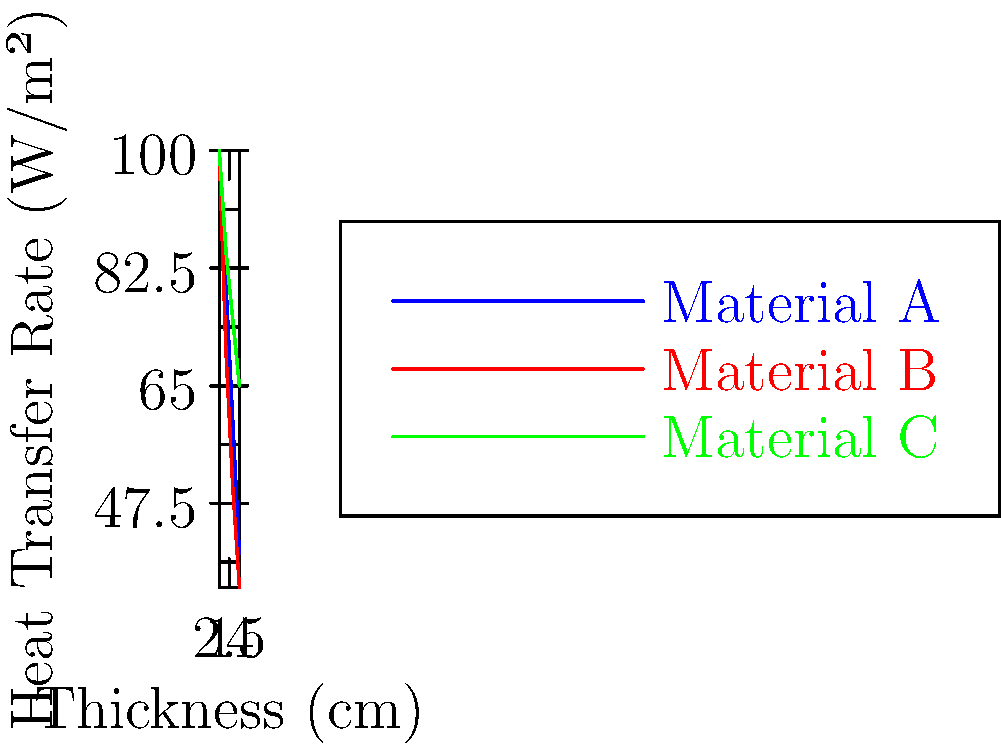As part of your research into genetic testing for breast cancer risk, you come across a study on heat transfer in medical equipment. The graph shows the heat transfer rates through three different insulation materials (A, B, and C) used in medical devices. Which material would be most effective for insulating a portable genetic testing device to maintain a stable internal temperature? To determine the most effective insulation material, we need to analyze the heat transfer rates for each material:

1. Understand the graph:
   - X-axis represents the thickness of the material in cm
   - Y-axis represents the heat transfer rate in W/m²
   - Lower heat transfer rates indicate better insulation

2. Compare the materials at maximum thickness (4 cm):
   - Material A: ~40 W/m²
   - Material B: ~35 W/m²
   - Material C: ~65 W/m²

3. Analyze the trends:
   - Material B consistently has the lowest heat transfer rate
   - Material A is close to B but slightly higher
   - Material C has the highest heat transfer rate throughout

4. Consider the relationship between thickness and insulation:
   - All materials show decreased heat transfer as thickness increases
   - Material B shows the steepest decline, indicating best performance per unit thickness

5. Conclusion:
   Material B is the most effective insulator because it has the lowest heat transfer rate at all thicknesses and shows the best improvement as thickness increases.
Answer: Material B 